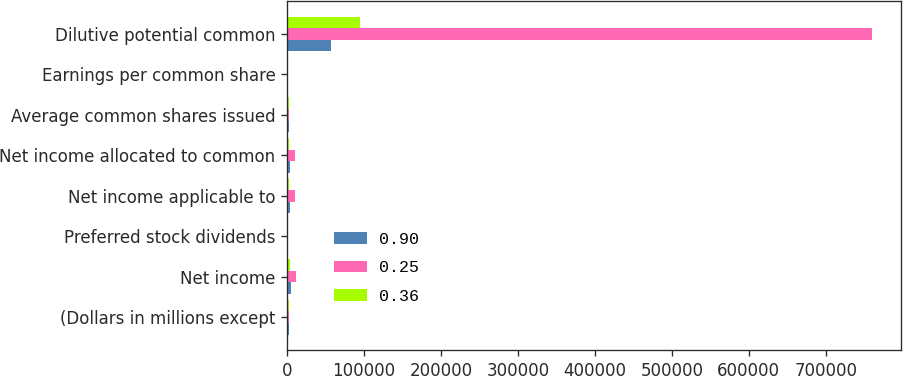Convert chart. <chart><loc_0><loc_0><loc_500><loc_500><stacked_bar_chart><ecel><fcel>(Dollars in millions except<fcel>Net income<fcel>Preferred stock dividends<fcel>Net income applicable to<fcel>Net income allocated to common<fcel>Average common shares issued<fcel>Earnings per common share<fcel>Dilutive potential common<nl><fcel>0.9<fcel>2014<fcel>4833<fcel>1044<fcel>3789<fcel>3789<fcel>2760<fcel>0.36<fcel>56717<nl><fcel>0.25<fcel>2013<fcel>11431<fcel>1349<fcel>10082<fcel>10080<fcel>2760<fcel>0.94<fcel>760253<nl><fcel>0.36<fcel>2012<fcel>4188<fcel>1428<fcel>2760<fcel>2758<fcel>2760<fcel>0.26<fcel>94826<nl></chart> 